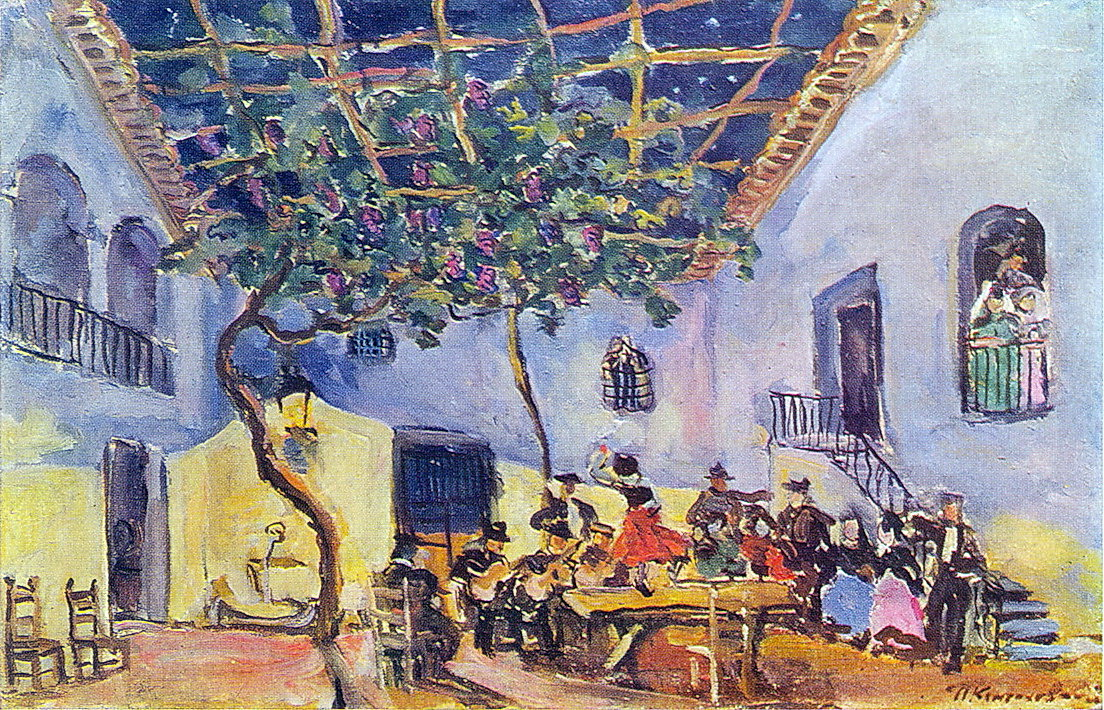Create a short story based on a day in the life of someone depicted in the painting. The sun rose gently, casting a golden glow across the courtyard. Maria, dressed in her vibrant red skirt, inhaled deeply the fresh scent of blooming flowers. Today was a day of celebration; her cousin’s wedding was to be held under the welcoming shade of the grand tree. As she carefully set the tables, arranging delicate pastries and pitchers of homemade wine, chatter and laughter began to fill the air. The guitarist tuned his instrument, and soon the notes of flamenco filled the space, inviting everyone to dance. Maria twirled and laughed, feeling a deep connection with her heritage and the warmth of her community. As evening fell, the courtyard buzzed softly with conversations and the hum of contented sighs, leaving Maria with a heart full of love and joy. 